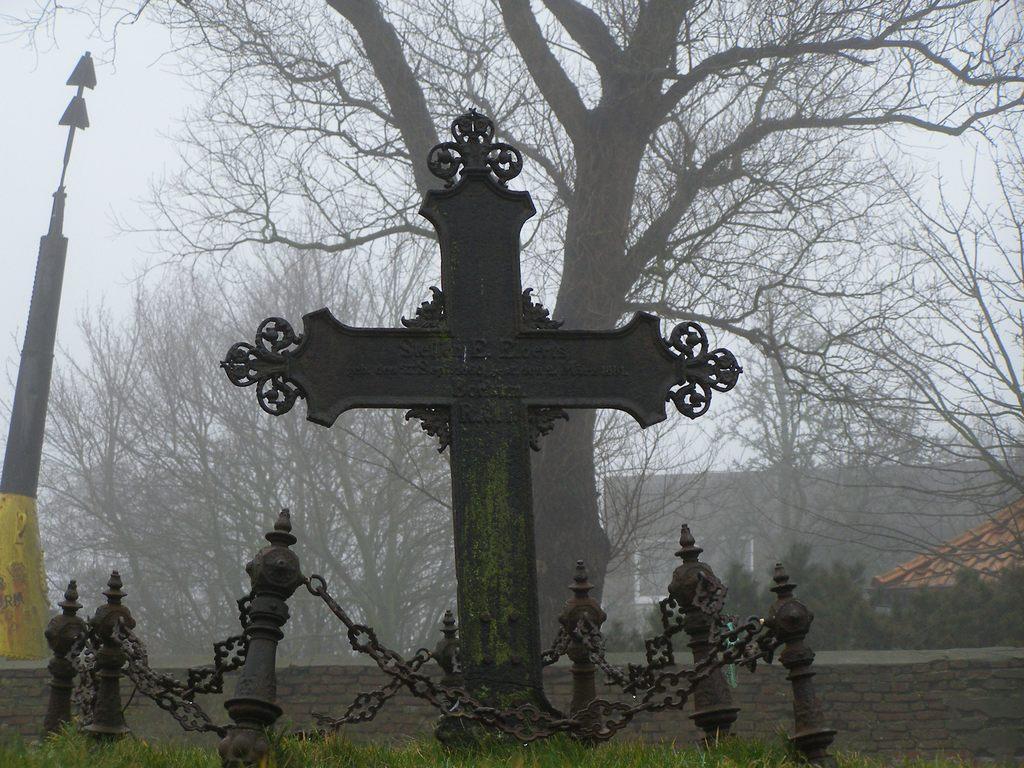Describe this image in one or two sentences. In this image there is a metal cross. Around the metal cross there is a metal chain fence. At the bottom of the image there is grass on the surface. On the left side of the image there is an arrow like structure. In the background of the image there is a wall. There are trees, buildings and sky. 